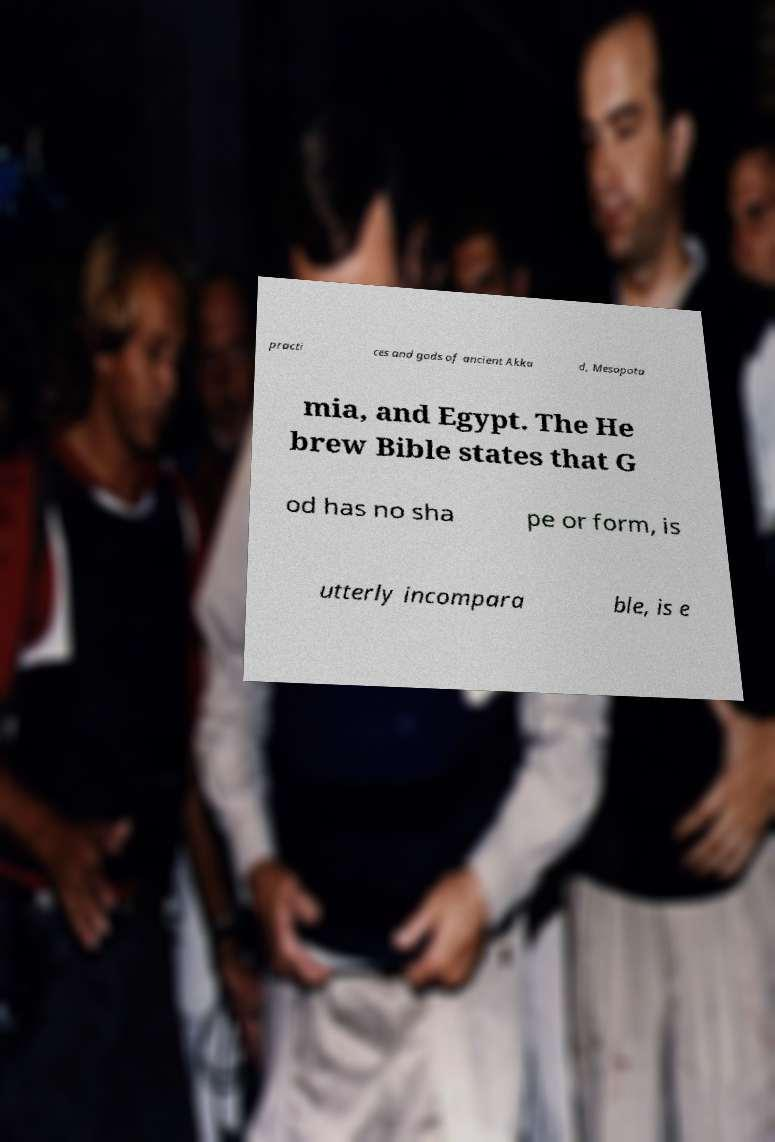Could you extract and type out the text from this image? practi ces and gods of ancient Akka d, Mesopota mia, and Egypt. The He brew Bible states that G od has no sha pe or form, is utterly incompara ble, is e 